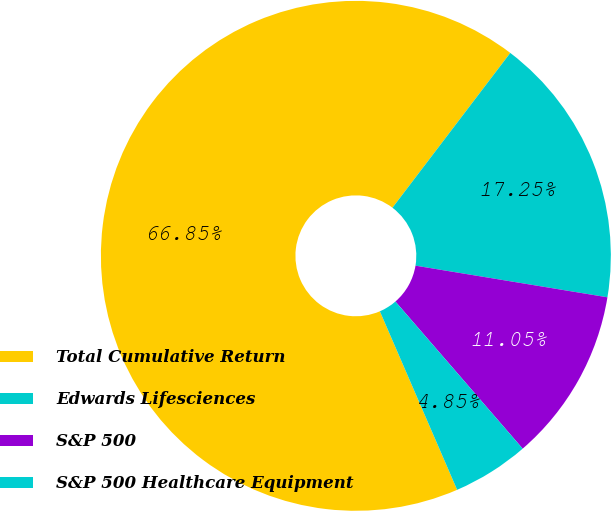Convert chart to OTSL. <chart><loc_0><loc_0><loc_500><loc_500><pie_chart><fcel>Total Cumulative Return<fcel>Edwards Lifesciences<fcel>S&P 500<fcel>S&P 500 Healthcare Equipment<nl><fcel>66.86%<fcel>17.25%<fcel>11.05%<fcel>4.85%<nl></chart> 